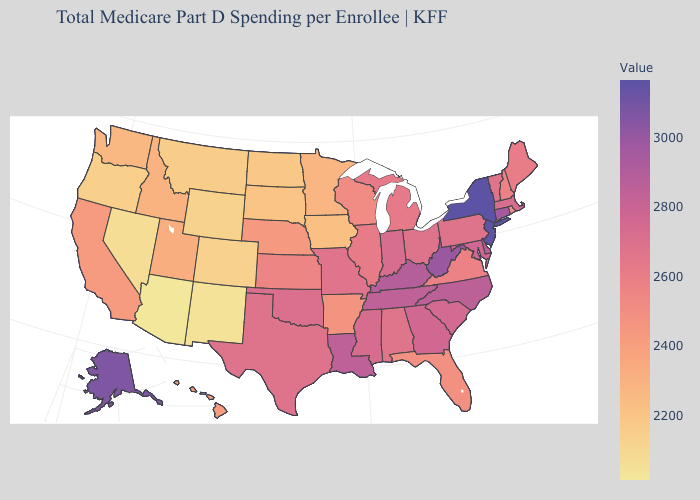Which states hav the highest value in the MidWest?
Quick response, please. Indiana. Among the states that border Washington , which have the lowest value?
Keep it brief. Oregon. Does West Virginia have the highest value in the South?
Quick response, please. Yes. Is the legend a continuous bar?
Answer briefly. Yes. Does North Dakota have the lowest value in the MidWest?
Answer briefly. Yes. 